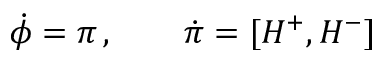<formula> <loc_0><loc_0><loc_500><loc_500>\dot { \phi } = \pi \, , \quad \dot { \pi } = [ H ^ { + } , H ^ { - } ]</formula> 